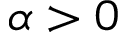Convert formula to latex. <formula><loc_0><loc_0><loc_500><loc_500>\alpha > 0</formula> 